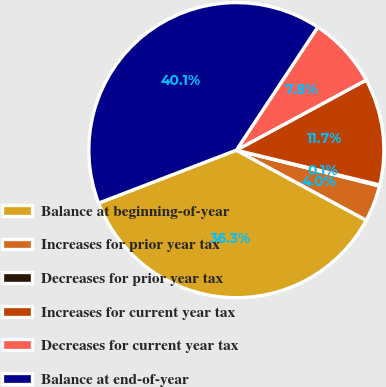<chart> <loc_0><loc_0><loc_500><loc_500><pie_chart><fcel>Balance at beginning-of-year<fcel>Increases for prior year tax<fcel>Decreases for prior year tax<fcel>Increases for current year tax<fcel>Decreases for current year tax<fcel>Balance at end-of-year<nl><fcel>36.28%<fcel>3.97%<fcel>0.12%<fcel>11.67%<fcel>7.82%<fcel>40.14%<nl></chart> 